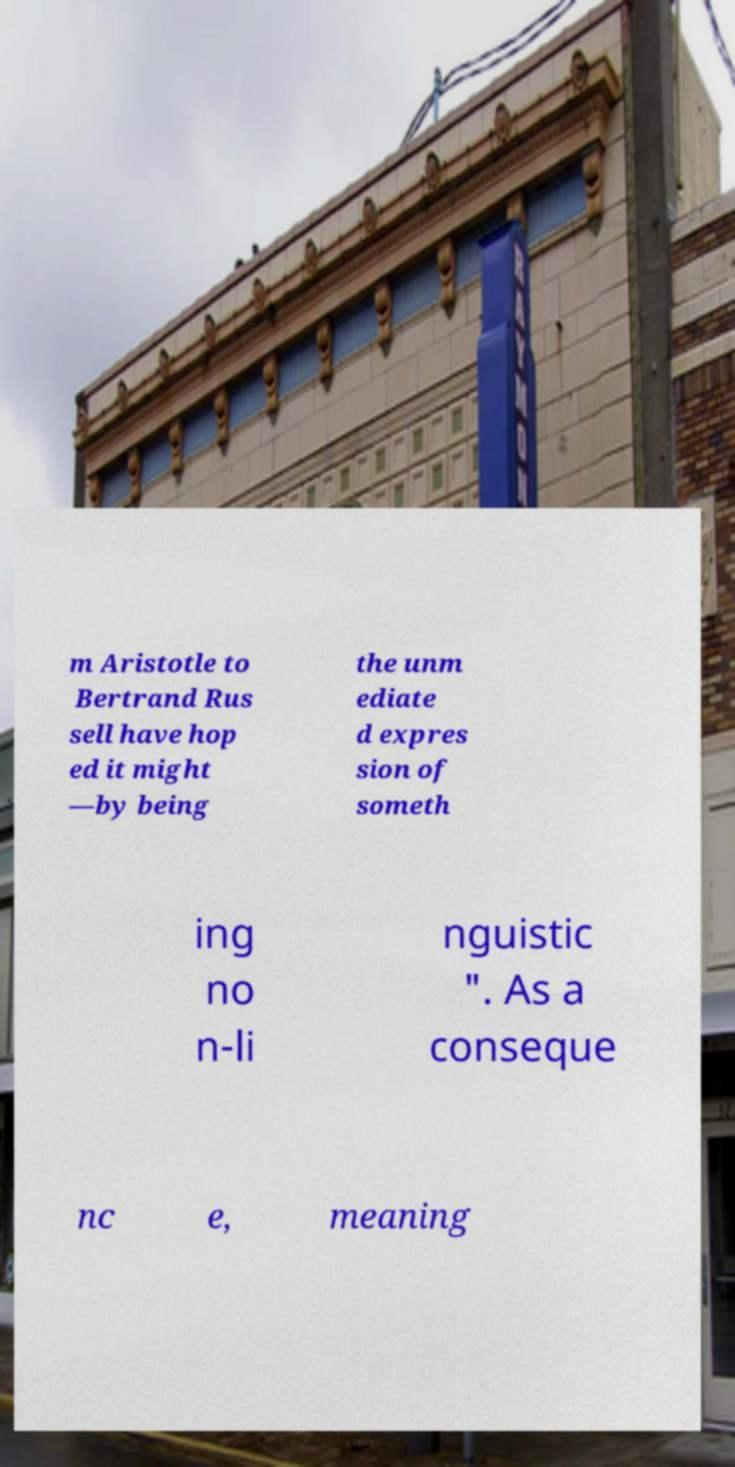What messages or text are displayed in this image? I need them in a readable, typed format. m Aristotle to Bertrand Rus sell have hop ed it might —by being the unm ediate d expres sion of someth ing no n-li nguistic ". As a conseque nc e, meaning 